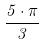<formula> <loc_0><loc_0><loc_500><loc_500>\frac { 5 \cdot \pi } { 3 }</formula> 